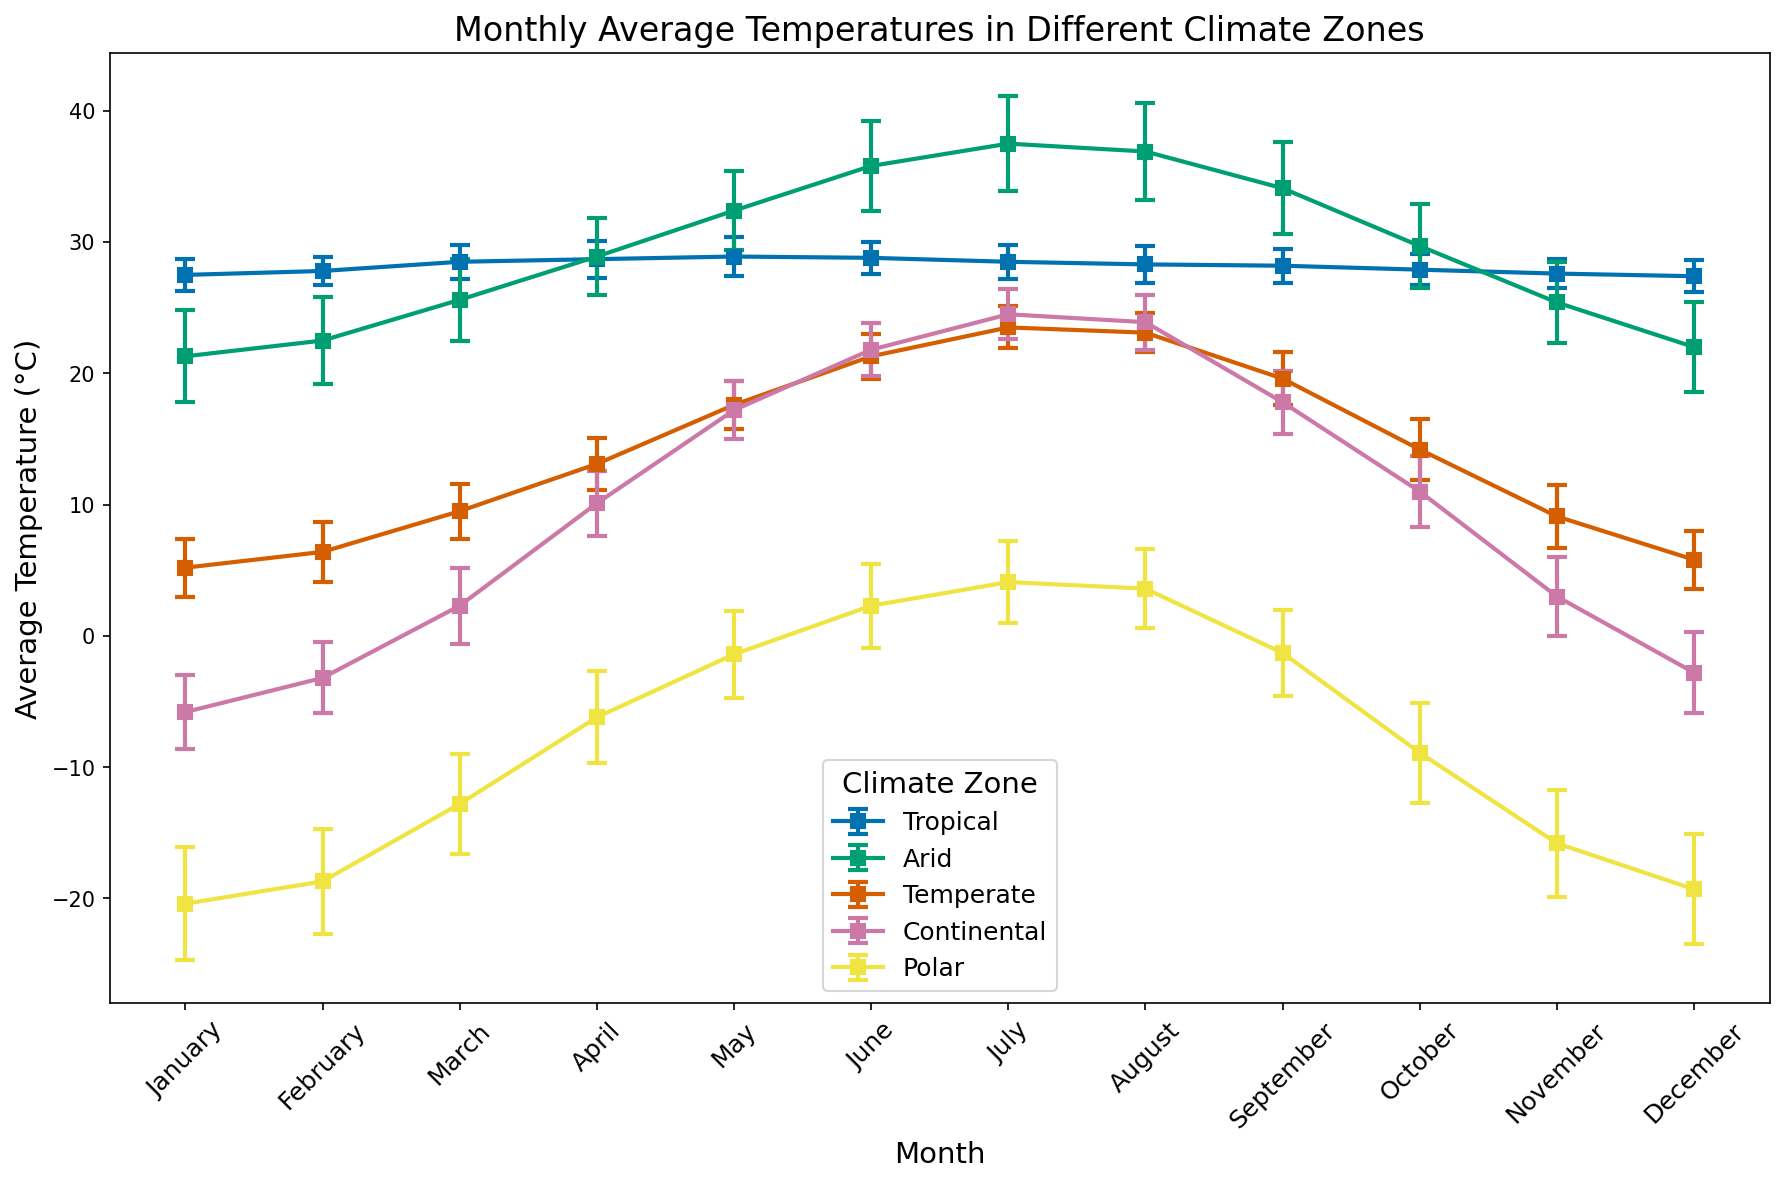Which climate zone has the highest average temperature in July? Look at the data points for July in each climate zone and compare the average temperatures. Tropical has 28.5°C, Arid has 37.5°C, Temperate has 23.5°C, Continental has 24.5°C, and Polar has 4.1°C. Arid has the highest average temperature.
Answer: Arid Which month shows the largest variation in temperature for the Arid climate zone? Look at the standard deviations for each month in the Arid climate zone. The largest standard deviation corresponds to the largest variation in temperature. The standard deviation is highest in August at 3.7°C.
Answer: August Calculate the average annual temperature for the Temperate climate zone using the monthly data. Add up the average temperatures for each month in the Temperate climate zone and then divide by 12. The sum of the monthly temperatures is 177.3°C. 177.3 / 12 = 14.775°C.
Answer: 14.775°C Compare the standard deviation of temperatures in January between the Continental and Polar climate zones. Which one is greater? Look at the standard deviations for January in both zones. January in the Continental zone has a standard deviation of 2.8°C and in the Polar zone, it is 4.3°C. Polar has a greater standard deviation.
Answer: Polar Which climate zone has the warmest month-on-average across all months? Look for the highest average temperature irrespective of the month for each climate zone. The highest values are Tropical at 28.9°C, Arid at 37.5°C, Temperate at 23.5°C, Continental at 24.5°C, and Polar at 4.1°C. Arid has the warmest month at 37.5°C in July.
Answer: Arid Is the temperature variation (standard deviation) higher in Summer (June-August) or Winter (December-February) for the Polar climate zone? Calculate the average standard deviation for Summer (June-August) and Winter (December-February) in the Polar climate zone. For Summer: (3.2 + 3.1 + 3.0)/3 = 3.1, and for Winter: (4.2 + 4.0 + 3.8)/3 = 4.0. The standard deviation is higher in Winter.
Answer: Winter Compare the month with the lowest temperature in the Tropical and Polar climate zones. Which one has a lower temperature, and how much lower? Look at the lowest average monthly temperature in the Tropical climate zone (27.4°C in December) and the lowest in the Polar climate zone (-20.4°C in January). Polar has a lower temperature, and the difference is 27.4 - (-20.4) = 47.8°C.
Answer: Polar, 47.8°C Identify the climate zone with the smallest temperature difference between the warmest and the coldest month. Calculate the temperature difference between the warmest and the coldest month in each climate zone. Tropical: 28.9 - 27.4 = 1.5°C, Arid: 37.5 - 21.3 = 16.2°C, Temperate: 23.5 - 5.2 = 18.3°C, Continental: 24.5 - (-5.8) = 30.3°C, Polar: 4.1 - (-20.4) = 24.5°C. Tropical has the smallest difference of 1.5°C.
Answer: Tropical 